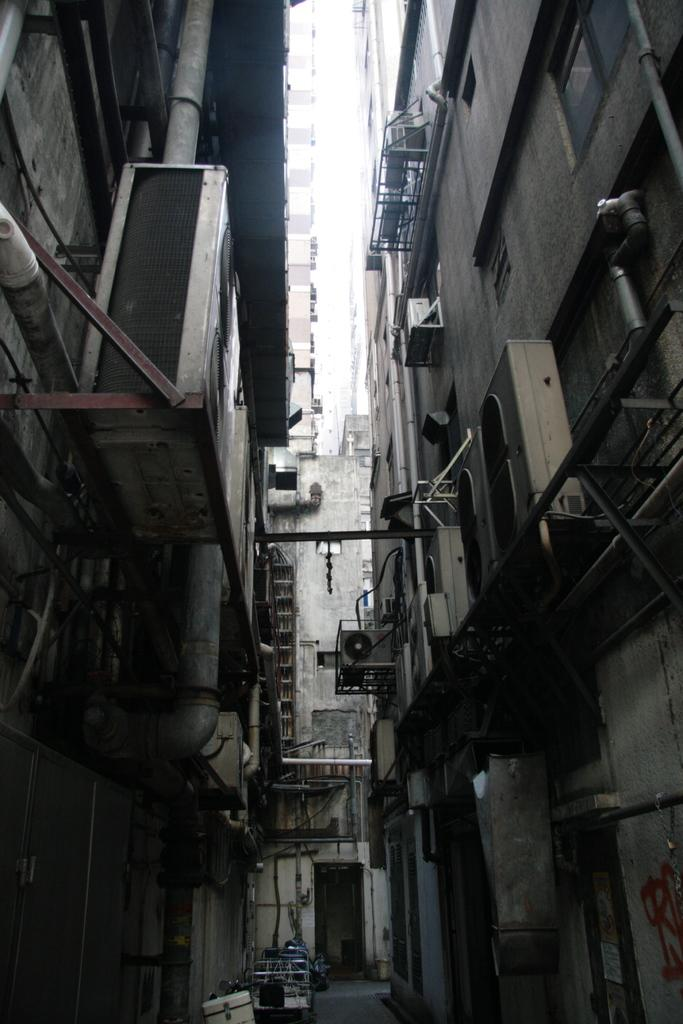What structures are located on both sides of the image? There are buildings on either side of the image. What can be seen in the middle of the image? There is a path in the middle of the image. What is visible above the path in the image? The sky is visible above the path. Can you see a crown on the head of a boy in the image? There is no boy or crown present in the image. What nation is depicted in the image? The image does not depict any specific nation; it shows buildings, a path, and the sky. 